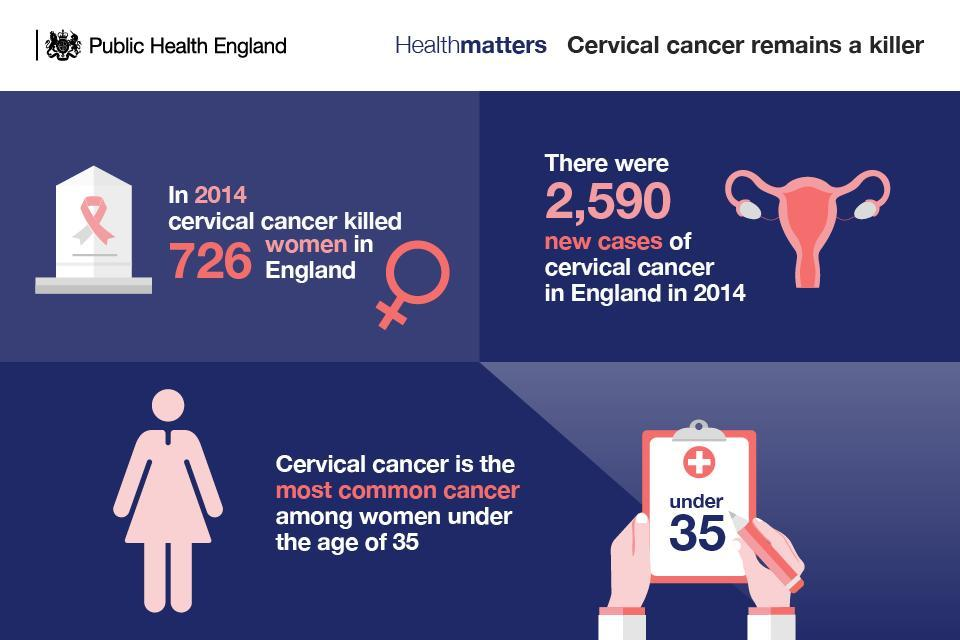How may times the word "cervical cancer" appeared in this infographic?
Answer the question with a short phrase. 4 What is the color of the icon given to represent women - pink, blue or white? White What are the numbers appeared at least once in this infographic other than 2014? 726, 2590, 35 How may times the year "2014" appeared in this infographic? 2 In which color the word "age of 35" is written - blue, black or white? white In the second graphics, which color is used as background color - blue, black or white? blue Which number is higher - number of new cases of cervical cancer or number of woman killed because of that in 2014? new cases of cervical cancer Which age group is specifically mentioned in the bottom half? under 35 new patients of cervical cancer in 2014 is? 2,590 How may times the number "35" appeared in this infographic? 2 